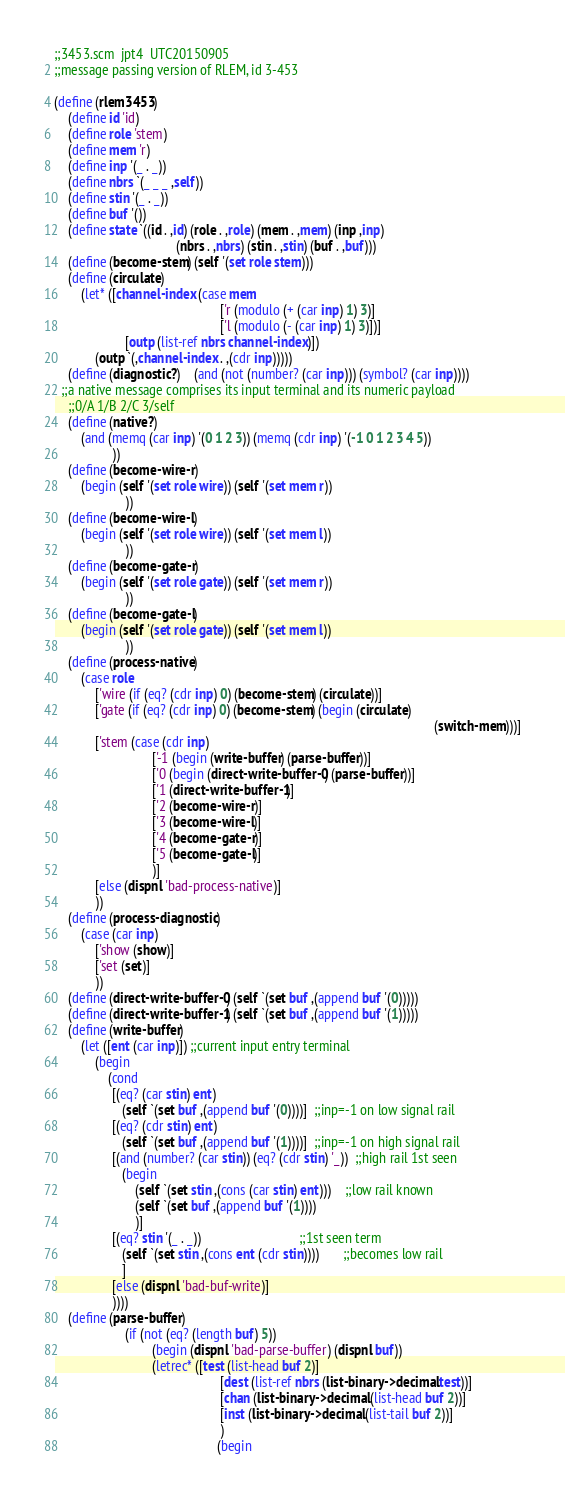Convert code to text. <code><loc_0><loc_0><loc_500><loc_500><_Scheme_>;;3453.scm  jpt4  UTC20150905
;;message passing version of RLEM, id 3-453

(define (rlem3453)
	(define id 'id)
	(define role 'stem)
	(define mem 'r)
	(define inp '(_ . _))
	(define nbrs `(_ _ _ ,self))
	(define stin '(_ . _))
	(define buf '())
	(define state `((id . ,id) (role . ,role) (mem . ,mem) (inp ,inp) 
									(nbrs . ,nbrs) (stin . ,stin) (buf . ,buf)))
	(define (become-stem) (self '(set role stem)))		
	(define (circulate)
		(let* ([channel-index (case mem
												 ['r (modulo (+ (car inp) 1) 3)]
												 ['l (modulo (- (car inp) 1) 3)])]
					 [outp (list-ref nbrs channel-index)])
			(outp `(,channel-index . ,(cdr inp)))))
	(define (diagnostic?)	(and (not (number? (car inp))) (symbol? (car inp))))
  ;;a native message comprises its input terminal and its numeric payload
	;;0/A 1/B 2/C 3/self
	(define (native?)
		(and (memq (car inp) '(0 1 2 3)) (memq (cdr inp) '(-1 0 1 2 3 4 5))
				 ))		
	(define (become-wire-r)
		(begin (self '(set role wire)) (self '(set mem r))
					 ))
	(define (become-wire-l)
		(begin (self '(set role wire)) (self '(set mem l))
					 ))
	(define (become-gate-r)
		(begin (self '(set role gate)) (self '(set mem r))
					 ))
	(define (become-gate-l)
		(begin (self '(set role gate)) (self '(set mem l))
					 ))
	(define (process-native)
		(case role
			['wire (if (eq? (cdr inp) 0) (become-stem) (circulate))]
			['gate (if (eq? (cdr inp) 0) (become-stem) (begin (circulate) 
																												(switch-mem)))]
			['stem (case (cdr inp)
							 ['-1 (begin (write-buffer) (parse-buffer))]
							 ['0 (begin (direct-write-buffer-0) (parse-buffer))]
							 ['1 (direct-write-buffer-1)]
							 ['2 (become-wire-r)]
							 ['3 (become-wire-l)]
							 ['4 (become-gate-r)]
							 ['5 (become-gate-l)]
							 )]
			[else (dispnl 'bad-process-native)]
			))						
	(define (process-diagnostic)
		(case (car inp)
			['show (show)]
			['set (set)]
			))			
	(define (direct-write-buffer-0) (self `(set buf ,(append buf '(0)))))
	(define (direct-write-buffer-1) (self `(set buf ,(append buf '(1)))))
	(define (write-buffer)
		(let ([ent (car inp)]) ;;current input entry terminal
			(begin
				(cond
				 [(eq? (car stin) ent)
					(self `(set buf ,(append buf '(0))))]  ;;inp=-1 on low signal rail
				 [(eq? (cdr stin) ent)
					(self `(set buf ,(append buf '(1))))]  ;;inp=-1 on high signal rail
				 [(and (number? (car stin)) (eq? (cdr stin) '_))  ;;high rail 1st seen
					(begin
						(self `(set stin ,(cons (car stin) ent)))    ;;low rail known
						(self `(set buf ,(append buf '(1))))
						)]
				 [(eq? stin '(_ . _))                             ;;1st seen term
					(self `(set stin ,(cons ent (cdr stin))))       ;;becomes low rail
					]
				 [else (dispnl 'bad-buf-write)]
				 ))))
	(define (parse-buffer)
					 (if (not (eq? (length buf) 5))
							 (begin (dispnl 'bad-parse-buffer) (dispnl buf))
							 (letrec* ([test (list-head buf 2)]
												 [dest (list-ref nbrs (list-binary->decimal test))]
												 [chan (list-binary->decimal (list-head buf 2))]
												 [inst (list-binary->decimal (list-tail buf 2))]
												 )
												(begin</code> 